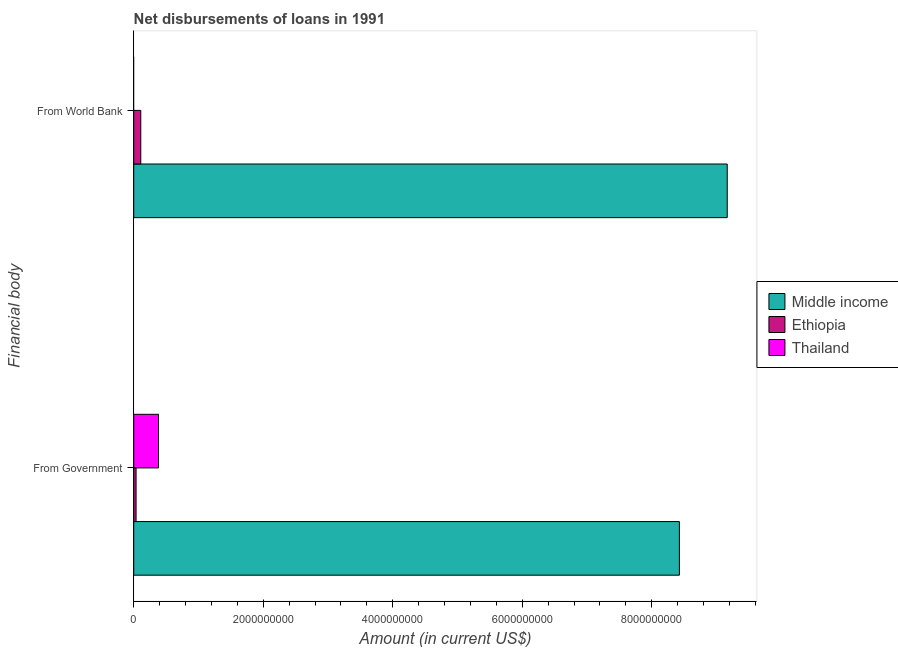How many groups of bars are there?
Ensure brevity in your answer.  2. Are the number of bars per tick equal to the number of legend labels?
Give a very brief answer. No. Are the number of bars on each tick of the Y-axis equal?
Give a very brief answer. No. What is the label of the 2nd group of bars from the top?
Make the answer very short. From Government. Across all countries, what is the maximum net disbursements of loan from world bank?
Your answer should be compact. 9.17e+09. What is the total net disbursements of loan from world bank in the graph?
Your response must be concise. 9.28e+09. What is the difference between the net disbursements of loan from government in Thailand and that in Ethiopia?
Ensure brevity in your answer.  3.46e+08. What is the difference between the net disbursements of loan from government in Middle income and the net disbursements of loan from world bank in Thailand?
Give a very brief answer. 8.43e+09. What is the average net disbursements of loan from government per country?
Ensure brevity in your answer.  2.95e+09. What is the difference between the net disbursements of loan from government and net disbursements of loan from world bank in Ethiopia?
Offer a terse response. -7.26e+07. What is the ratio of the net disbursements of loan from government in Ethiopia to that in Middle income?
Offer a very short reply. 0. Is the net disbursements of loan from government in Ethiopia less than that in Middle income?
Your answer should be very brief. Yes. How many bars are there?
Provide a short and direct response. 5. What is the difference between two consecutive major ticks on the X-axis?
Offer a terse response. 2.00e+09. Are the values on the major ticks of X-axis written in scientific E-notation?
Your answer should be very brief. No. Does the graph contain any zero values?
Provide a short and direct response. Yes. Where does the legend appear in the graph?
Ensure brevity in your answer.  Center right. How many legend labels are there?
Offer a terse response. 3. What is the title of the graph?
Make the answer very short. Net disbursements of loans in 1991. Does "Ghana" appear as one of the legend labels in the graph?
Your response must be concise. No. What is the label or title of the Y-axis?
Ensure brevity in your answer.  Financial body. What is the Amount (in current US$) of Middle income in From Government?
Make the answer very short. 8.43e+09. What is the Amount (in current US$) in Ethiopia in From Government?
Provide a succinct answer. 3.61e+07. What is the Amount (in current US$) of Thailand in From Government?
Make the answer very short. 3.83e+08. What is the Amount (in current US$) of Middle income in From World Bank?
Provide a succinct answer. 9.17e+09. What is the Amount (in current US$) of Ethiopia in From World Bank?
Give a very brief answer. 1.09e+08. What is the Amount (in current US$) of Thailand in From World Bank?
Give a very brief answer. 0. Across all Financial body, what is the maximum Amount (in current US$) in Middle income?
Provide a succinct answer. 9.17e+09. Across all Financial body, what is the maximum Amount (in current US$) in Ethiopia?
Keep it short and to the point. 1.09e+08. Across all Financial body, what is the maximum Amount (in current US$) in Thailand?
Provide a short and direct response. 3.83e+08. Across all Financial body, what is the minimum Amount (in current US$) in Middle income?
Keep it short and to the point. 8.43e+09. Across all Financial body, what is the minimum Amount (in current US$) of Ethiopia?
Your answer should be very brief. 3.61e+07. What is the total Amount (in current US$) of Middle income in the graph?
Offer a terse response. 1.76e+1. What is the total Amount (in current US$) of Ethiopia in the graph?
Keep it short and to the point. 1.45e+08. What is the total Amount (in current US$) in Thailand in the graph?
Offer a very short reply. 3.83e+08. What is the difference between the Amount (in current US$) of Middle income in From Government and that in From World Bank?
Provide a succinct answer. -7.39e+08. What is the difference between the Amount (in current US$) of Ethiopia in From Government and that in From World Bank?
Offer a terse response. -7.26e+07. What is the difference between the Amount (in current US$) in Middle income in From Government and the Amount (in current US$) in Ethiopia in From World Bank?
Offer a terse response. 8.32e+09. What is the average Amount (in current US$) in Middle income per Financial body?
Your answer should be compact. 8.80e+09. What is the average Amount (in current US$) of Ethiopia per Financial body?
Keep it short and to the point. 7.24e+07. What is the average Amount (in current US$) of Thailand per Financial body?
Give a very brief answer. 1.91e+08. What is the difference between the Amount (in current US$) in Middle income and Amount (in current US$) in Ethiopia in From Government?
Provide a short and direct response. 8.39e+09. What is the difference between the Amount (in current US$) in Middle income and Amount (in current US$) in Thailand in From Government?
Offer a terse response. 8.05e+09. What is the difference between the Amount (in current US$) in Ethiopia and Amount (in current US$) in Thailand in From Government?
Make the answer very short. -3.46e+08. What is the difference between the Amount (in current US$) in Middle income and Amount (in current US$) in Ethiopia in From World Bank?
Provide a short and direct response. 9.06e+09. What is the ratio of the Amount (in current US$) of Middle income in From Government to that in From World Bank?
Ensure brevity in your answer.  0.92. What is the ratio of the Amount (in current US$) in Ethiopia in From Government to that in From World Bank?
Your response must be concise. 0.33. What is the difference between the highest and the second highest Amount (in current US$) in Middle income?
Keep it short and to the point. 7.39e+08. What is the difference between the highest and the second highest Amount (in current US$) in Ethiopia?
Make the answer very short. 7.26e+07. What is the difference between the highest and the lowest Amount (in current US$) in Middle income?
Offer a very short reply. 7.39e+08. What is the difference between the highest and the lowest Amount (in current US$) of Ethiopia?
Keep it short and to the point. 7.26e+07. What is the difference between the highest and the lowest Amount (in current US$) in Thailand?
Your response must be concise. 3.83e+08. 